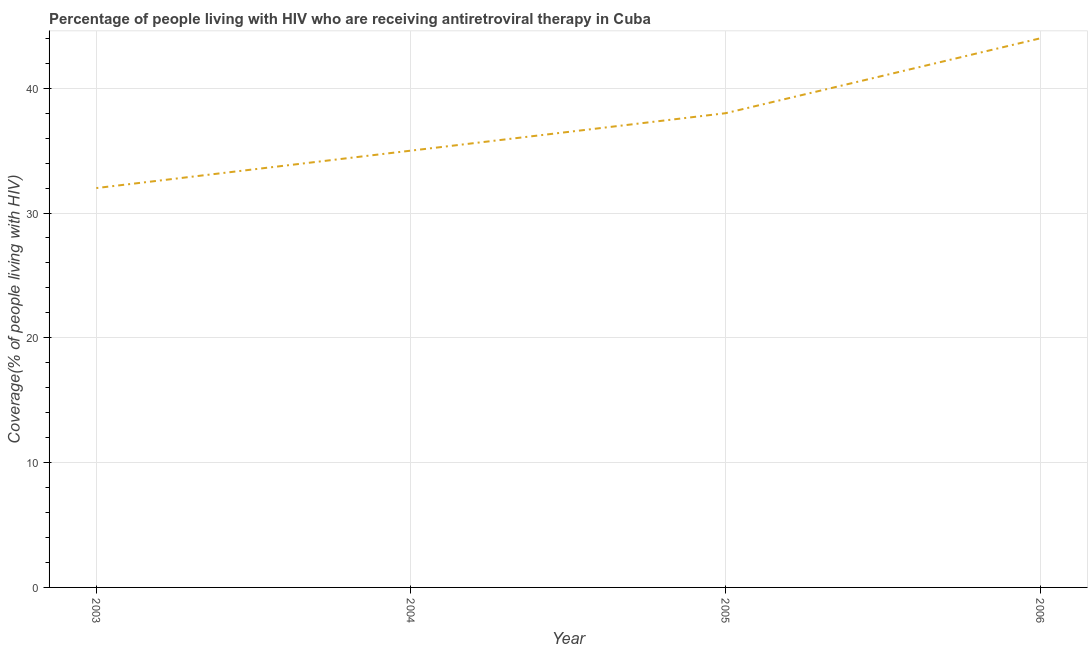What is the antiretroviral therapy coverage in 2003?
Your answer should be very brief. 32. Across all years, what is the maximum antiretroviral therapy coverage?
Your response must be concise. 44. Across all years, what is the minimum antiretroviral therapy coverage?
Keep it short and to the point. 32. In which year was the antiretroviral therapy coverage maximum?
Your answer should be compact. 2006. What is the sum of the antiretroviral therapy coverage?
Your response must be concise. 149. What is the difference between the antiretroviral therapy coverage in 2003 and 2005?
Make the answer very short. -6. What is the average antiretroviral therapy coverage per year?
Your response must be concise. 37.25. What is the median antiretroviral therapy coverage?
Your response must be concise. 36.5. Do a majority of the years between 2006 and 2004 (inclusive) have antiretroviral therapy coverage greater than 32 %?
Give a very brief answer. No. What is the ratio of the antiretroviral therapy coverage in 2004 to that in 2006?
Make the answer very short. 0.8. Is the difference between the antiretroviral therapy coverage in 2003 and 2004 greater than the difference between any two years?
Give a very brief answer. No. What is the difference between the highest and the second highest antiretroviral therapy coverage?
Your answer should be compact. 6. What is the difference between the highest and the lowest antiretroviral therapy coverage?
Your response must be concise. 12. In how many years, is the antiretroviral therapy coverage greater than the average antiretroviral therapy coverage taken over all years?
Give a very brief answer. 2. Does the antiretroviral therapy coverage monotonically increase over the years?
Your response must be concise. Yes. How many lines are there?
Give a very brief answer. 1. What is the difference between two consecutive major ticks on the Y-axis?
Ensure brevity in your answer.  10. Are the values on the major ticks of Y-axis written in scientific E-notation?
Keep it short and to the point. No. Does the graph contain any zero values?
Offer a terse response. No. What is the title of the graph?
Your response must be concise. Percentage of people living with HIV who are receiving antiretroviral therapy in Cuba. What is the label or title of the Y-axis?
Give a very brief answer. Coverage(% of people living with HIV). What is the Coverage(% of people living with HIV) of 2005?
Provide a short and direct response. 38. What is the Coverage(% of people living with HIV) in 2006?
Offer a very short reply. 44. What is the difference between the Coverage(% of people living with HIV) in 2003 and 2005?
Offer a terse response. -6. What is the difference between the Coverage(% of people living with HIV) in 2003 and 2006?
Ensure brevity in your answer.  -12. What is the difference between the Coverage(% of people living with HIV) in 2004 and 2005?
Your answer should be very brief. -3. What is the ratio of the Coverage(% of people living with HIV) in 2003 to that in 2004?
Provide a short and direct response. 0.91. What is the ratio of the Coverage(% of people living with HIV) in 2003 to that in 2005?
Keep it short and to the point. 0.84. What is the ratio of the Coverage(% of people living with HIV) in 2003 to that in 2006?
Give a very brief answer. 0.73. What is the ratio of the Coverage(% of people living with HIV) in 2004 to that in 2005?
Your response must be concise. 0.92. What is the ratio of the Coverage(% of people living with HIV) in 2004 to that in 2006?
Offer a very short reply. 0.8. What is the ratio of the Coverage(% of people living with HIV) in 2005 to that in 2006?
Make the answer very short. 0.86. 